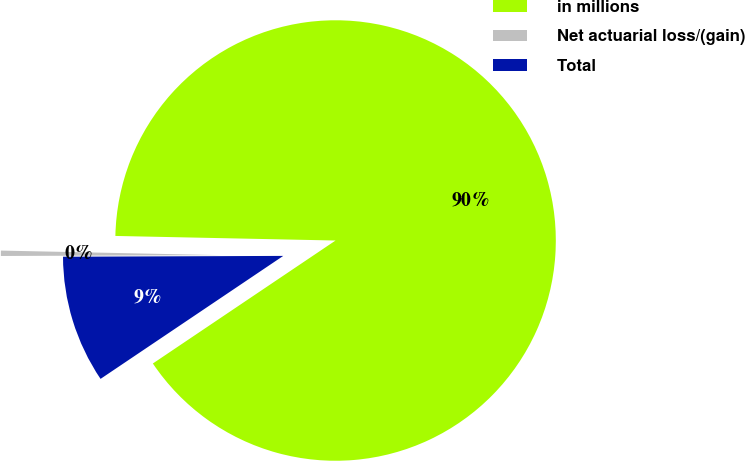<chart> <loc_0><loc_0><loc_500><loc_500><pie_chart><fcel>in millions<fcel>Net actuarial loss/(gain)<fcel>Total<nl><fcel>90.24%<fcel>0.39%<fcel>9.37%<nl></chart> 